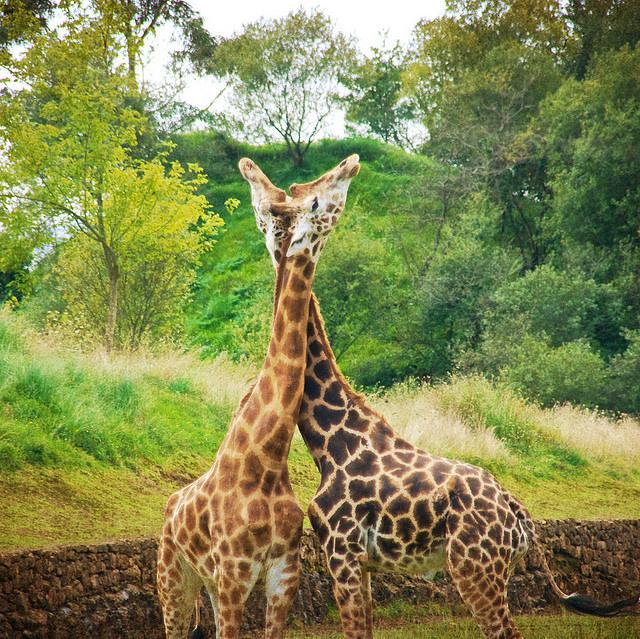Which zebra is a lighter color?
Keep it brief. No zebra. Does this animal have its eyes open?
Keep it brief. Yes. Is it day time or night time?
Write a very short answer. Day. Whose face is visible, the animal from the left or right?
Write a very short answer. Left. Do these giraffes get along?
Answer briefly. Yes. Are these baby giraffes?
Quick response, please. Yes. 